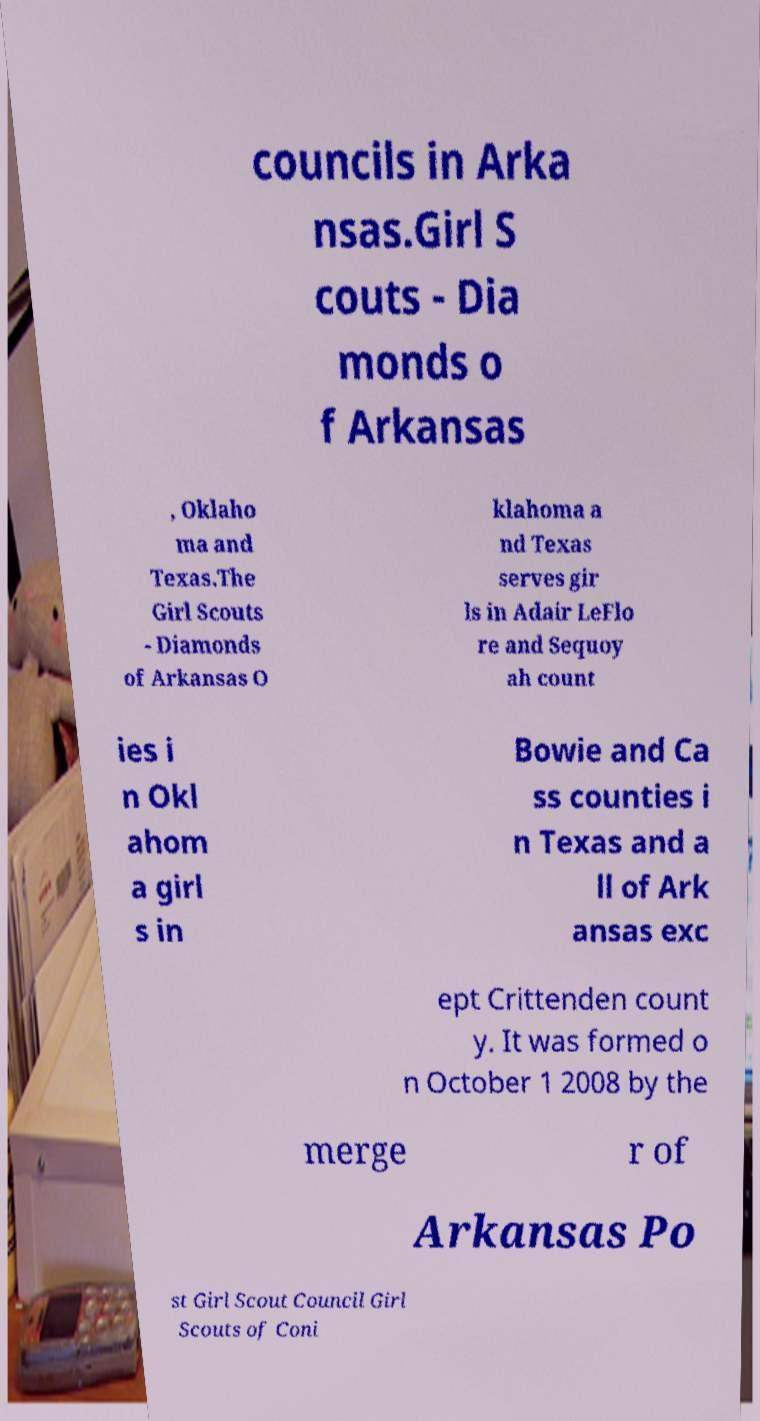Please identify and transcribe the text found in this image. councils in Arka nsas.Girl S couts - Dia monds o f Arkansas , Oklaho ma and Texas.The Girl Scouts - Diamonds of Arkansas O klahoma a nd Texas serves gir ls in Adair LeFlo re and Sequoy ah count ies i n Okl ahom a girl s in Bowie and Ca ss counties i n Texas and a ll of Ark ansas exc ept Crittenden count y. It was formed o n October 1 2008 by the merge r of Arkansas Po st Girl Scout Council Girl Scouts of Coni 